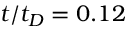Convert formula to latex. <formula><loc_0><loc_0><loc_500><loc_500>t / t _ { D } = 0 . 1 2</formula> 